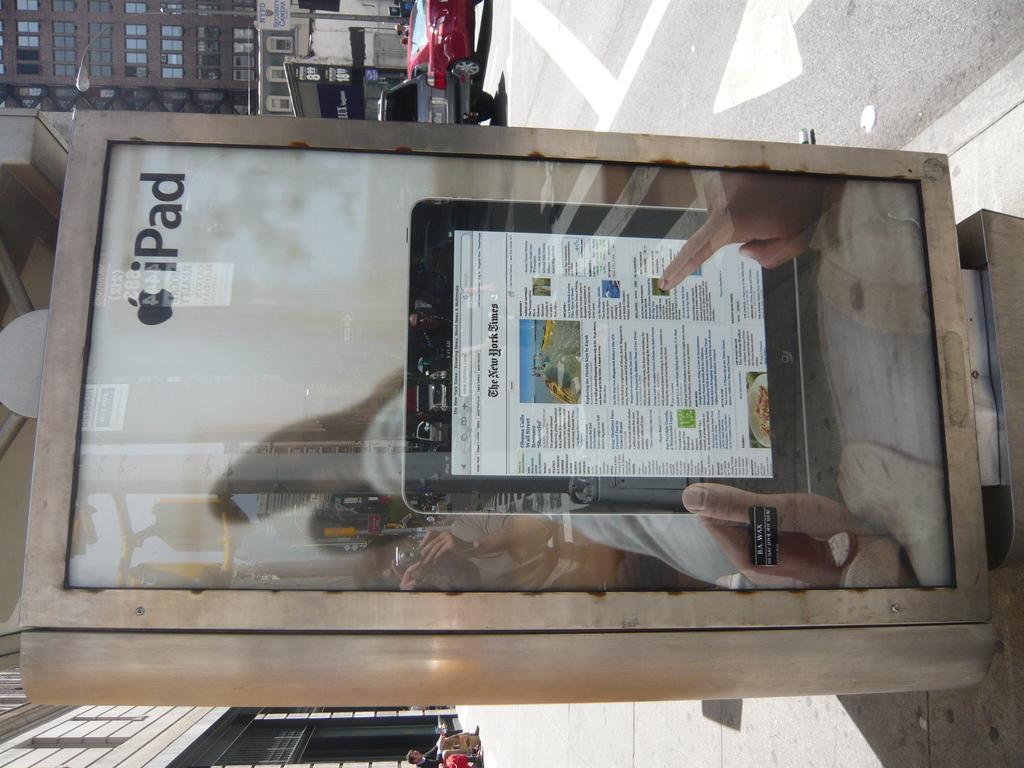How would you summarize this image in a sentence or two? In this image we can see a box with the image of person´s hand holding an iPad and there are vehicles on the road, there are few buildings, a light pole and a person sitting near the building. 